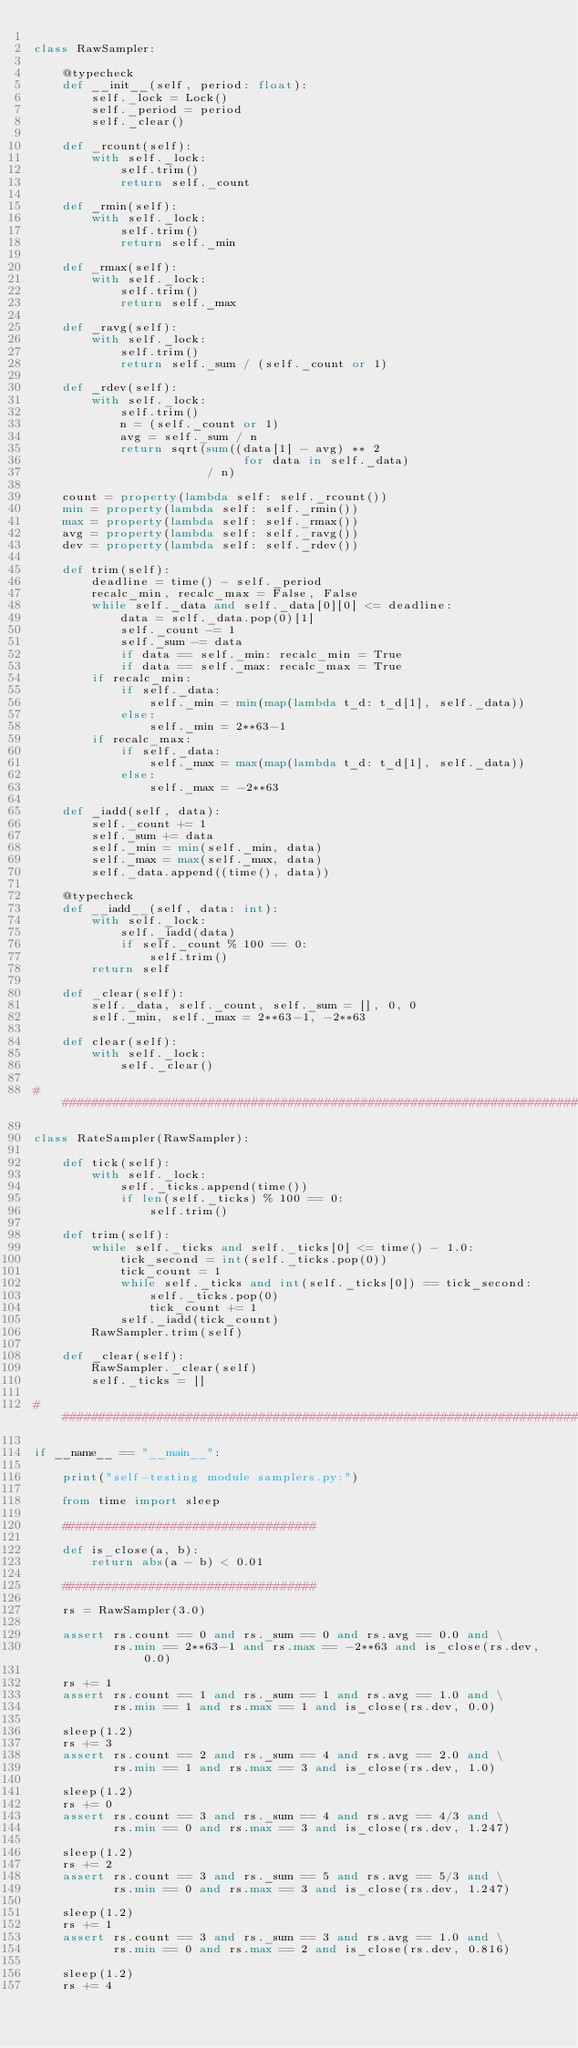Convert code to text. <code><loc_0><loc_0><loc_500><loc_500><_Python_>
class RawSampler:

    @typecheck
    def __init__(self, period: float):
        self._lock = Lock()
        self._period = period
        self._clear()

    def _rcount(self):
        with self._lock:
            self.trim()
            return self._count

    def _rmin(self):
        with self._lock:
            self.trim()
            return self._min

    def _rmax(self):
        with self._lock:
            self.trim()
            return self._max

    def _ravg(self):
        with self._lock:
            self.trim()
            return self._sum / (self._count or 1)

    def _rdev(self):
        with self._lock:
            self.trim()
            n = (self._count or 1)
            avg = self._sum / n
            return sqrt(sum((data[1] - avg) ** 2
                             for data in self._data)
                        / n)

    count = property(lambda self: self._rcount())
    min = property(lambda self: self._rmin())
    max = property(lambda self: self._rmax())
    avg = property(lambda self: self._ravg())
    dev = property(lambda self: self._rdev())

    def trim(self):
        deadline = time() - self._period
        recalc_min, recalc_max = False, False
        while self._data and self._data[0][0] <= deadline:
            data = self._data.pop(0)[1]
            self._count -= 1
            self._sum -= data
            if data == self._min: recalc_min = True
            if data == self._max: recalc_max = True
        if recalc_min:
            if self._data:
                self._min = min(map(lambda t_d: t_d[1], self._data))
            else:
                self._min = 2**63-1
        if recalc_max:
            if self._data:
                self._max = max(map(lambda t_d: t_d[1], self._data))
            else:
                self._max = -2**63

    def _iadd(self, data):
        self._count += 1
        self._sum += data
        self._min = min(self._min, data)
        self._max = max(self._max, data)
        self._data.append((time(), data))

    @typecheck
    def __iadd__(self, data: int):
        with self._lock:
            self._iadd(data)
            if self._count % 100 == 0:
                self.trim()
        return self

    def _clear(self):
        self._data, self._count, self._sum = [], 0, 0
        self._min, self._max = 2**63-1, -2**63

    def clear(self):
        with self._lock:
            self._clear()

################################################################################

class RateSampler(RawSampler):

    def tick(self):
        with self._lock:
            self._ticks.append(time())
            if len(self._ticks) % 100 == 0:
                self.trim()

    def trim(self):
        while self._ticks and self._ticks[0] <= time() - 1.0:
            tick_second = int(self._ticks.pop(0))
            tick_count = 1
            while self._ticks and int(self._ticks[0]) == tick_second:
                self._ticks.pop(0)
                tick_count += 1
            self._iadd(tick_count)
        RawSampler.trim(self)

    def _clear(self):
        RawSampler._clear(self)
        self._ticks = []

################################################################################

if __name__ == "__main__":

    print("self-testing module samplers.py:")

    from time import sleep

    ###################################

    def is_close(a, b):
        return abs(a - b) < 0.01

    ###################################

    rs = RawSampler(3.0)

    assert rs.count == 0 and rs._sum == 0 and rs.avg == 0.0 and \
           rs.min == 2**63-1 and rs.max == -2**63 and is_close(rs.dev, 0.0)

    rs += 1
    assert rs.count == 1 and rs._sum == 1 and rs.avg == 1.0 and \
           rs.min == 1 and rs.max == 1 and is_close(rs.dev, 0.0)

    sleep(1.2)
    rs += 3
    assert rs.count == 2 and rs._sum == 4 and rs.avg == 2.0 and \
           rs.min == 1 and rs.max == 3 and is_close(rs.dev, 1.0)

    sleep(1.2)
    rs += 0
    assert rs.count == 3 and rs._sum == 4 and rs.avg == 4/3 and \
           rs.min == 0 and rs.max == 3 and is_close(rs.dev, 1.247)

    sleep(1.2)
    rs += 2
    assert rs.count == 3 and rs._sum == 5 and rs.avg == 5/3 and \
           rs.min == 0 and rs.max == 3 and is_close(rs.dev, 1.247)

    sleep(1.2)
    rs += 1
    assert rs.count == 3 and rs._sum == 3 and rs.avg == 1.0 and \
           rs.min == 0 and rs.max == 2 and is_close(rs.dev, 0.816)

    sleep(1.2)
    rs += 4</code> 